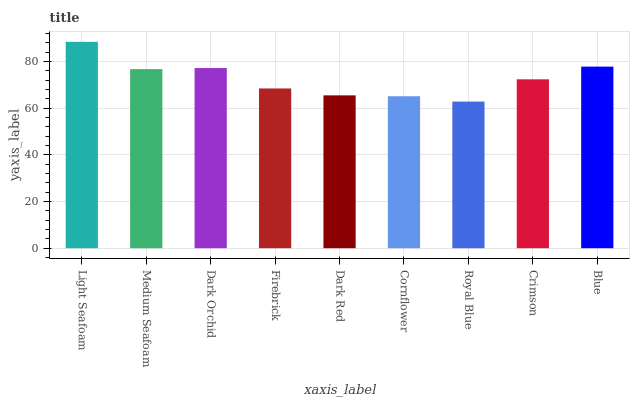Is Royal Blue the minimum?
Answer yes or no. Yes. Is Light Seafoam the maximum?
Answer yes or no. Yes. Is Medium Seafoam the minimum?
Answer yes or no. No. Is Medium Seafoam the maximum?
Answer yes or no. No. Is Light Seafoam greater than Medium Seafoam?
Answer yes or no. Yes. Is Medium Seafoam less than Light Seafoam?
Answer yes or no. Yes. Is Medium Seafoam greater than Light Seafoam?
Answer yes or no. No. Is Light Seafoam less than Medium Seafoam?
Answer yes or no. No. Is Crimson the high median?
Answer yes or no. Yes. Is Crimson the low median?
Answer yes or no. Yes. Is Dark Red the high median?
Answer yes or no. No. Is Dark Red the low median?
Answer yes or no. No. 